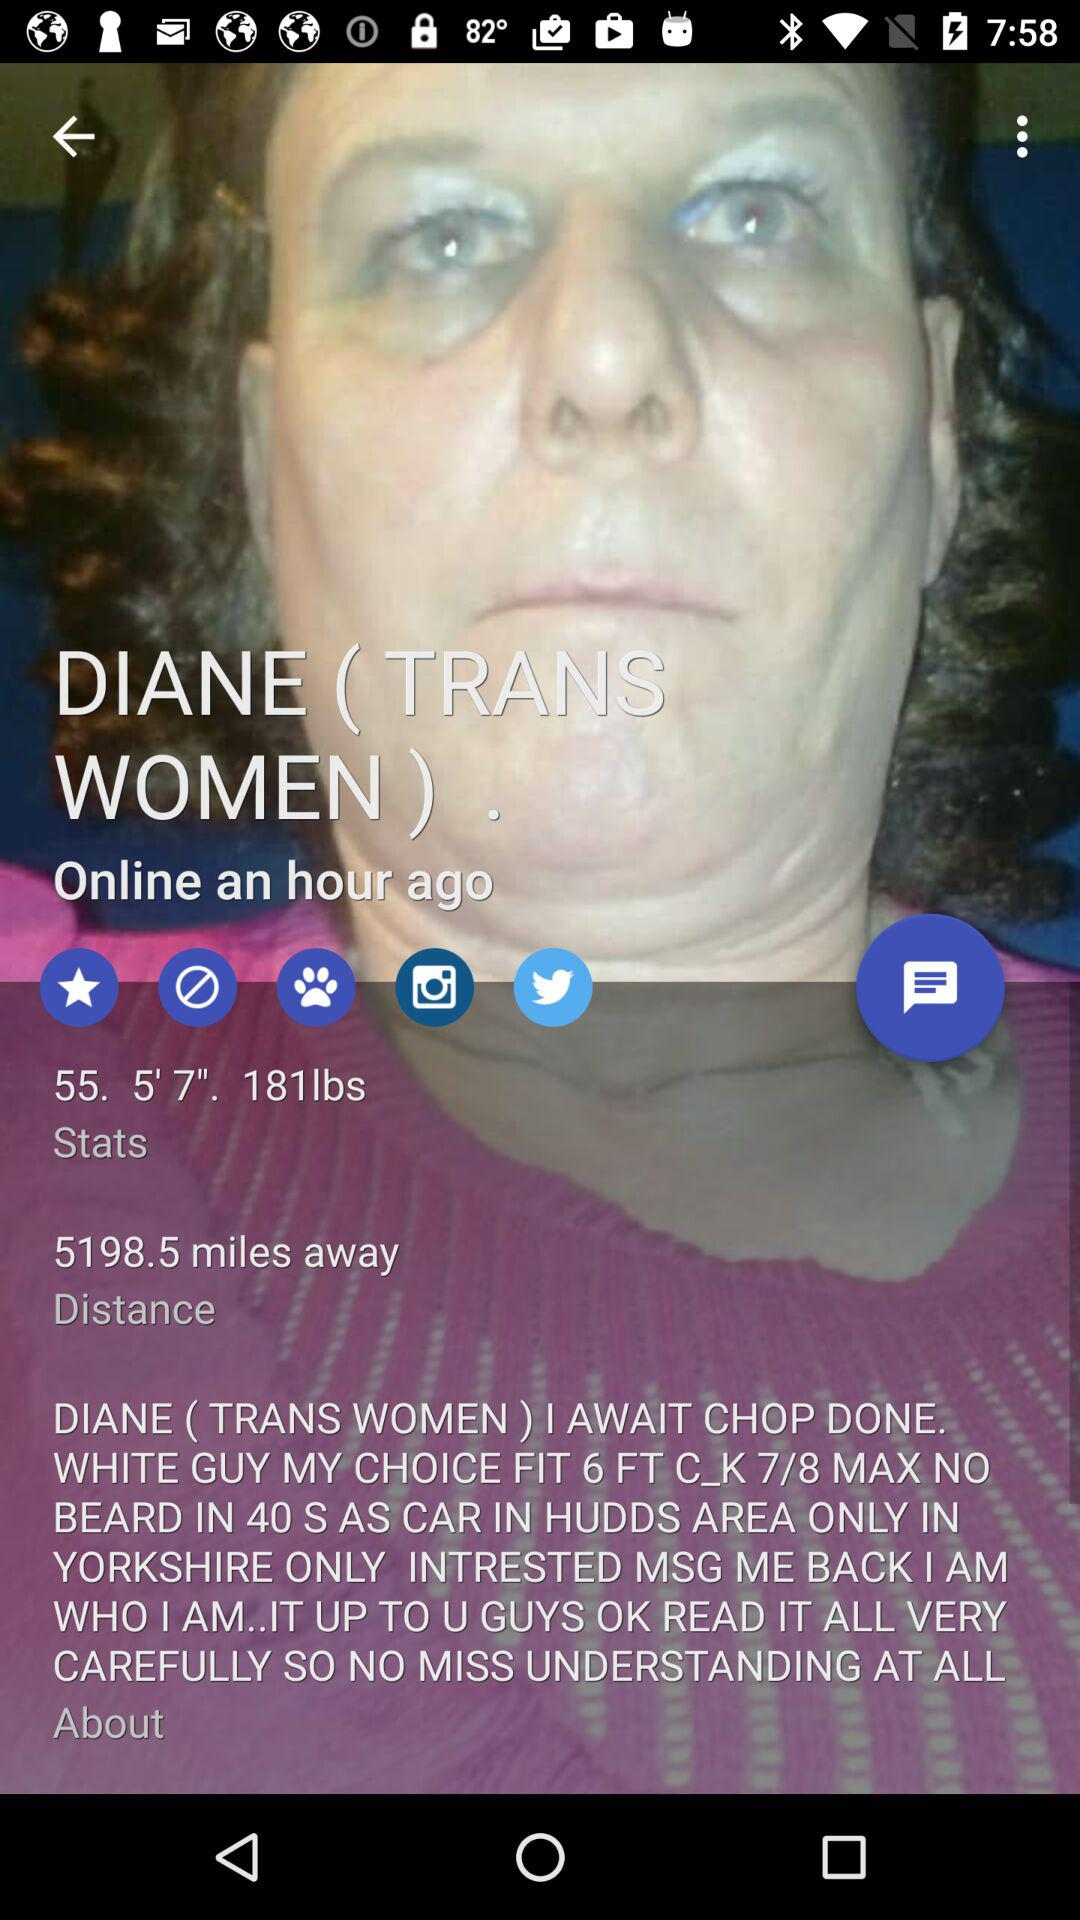What is the given name? The given name is Diane. 